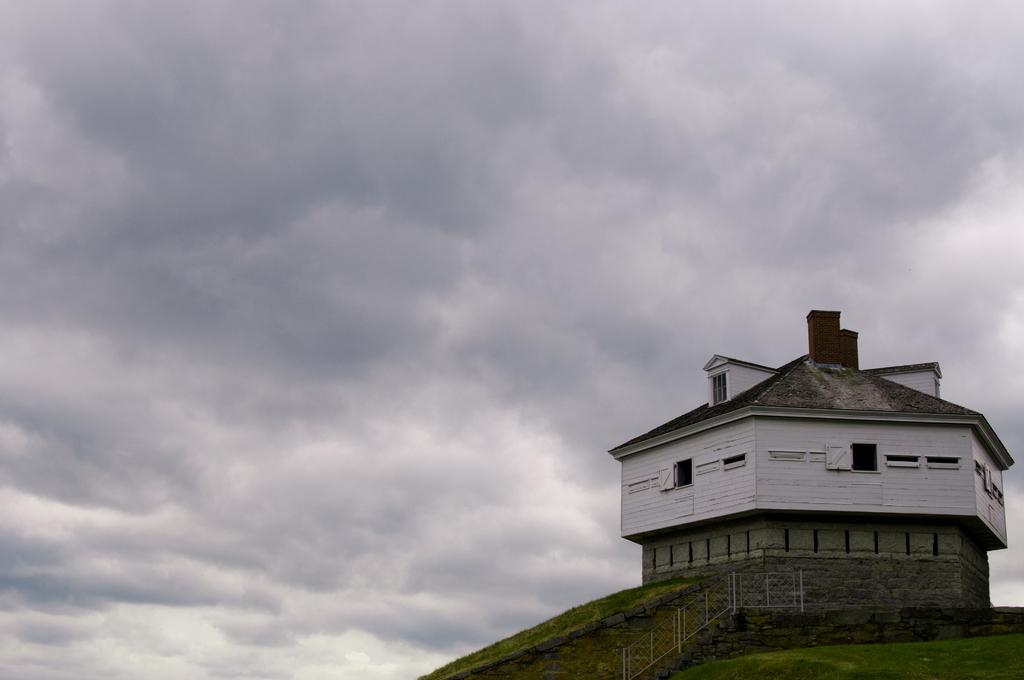What structure is located on the right side of the image? There is a building on the right side of the image. What can be seen in the background of the image? There are clouds visible in the sky in the background of the image. What type of breakfast is being served on the street in the image? There is no street or breakfast present in the image; it only features a building and clouds in the sky. 